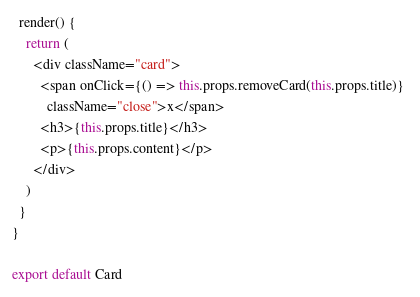<code> <loc_0><loc_0><loc_500><loc_500><_JavaScript_>
  render() {
    return (
      <div className="card">
        <span onClick={() => this.props.removeCard(this.props.title)} 
          className="close">x</span>
        <h3>{this.props.title}</h3>
        <p>{this.props.content}</p>
      </div>
    )
  }
}

export default Card</code> 